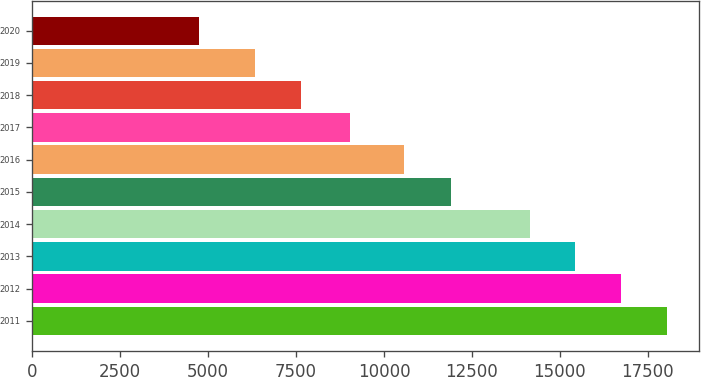Convert chart to OTSL. <chart><loc_0><loc_0><loc_500><loc_500><bar_chart><fcel>2011<fcel>2012<fcel>2013<fcel>2014<fcel>2015<fcel>2016<fcel>2017<fcel>2018<fcel>2019<fcel>2020<nl><fcel>18055.4<fcel>16749.7<fcel>15444<fcel>14138<fcel>11919<fcel>10561<fcel>9031<fcel>7627.7<fcel>6322<fcel>4732<nl></chart> 